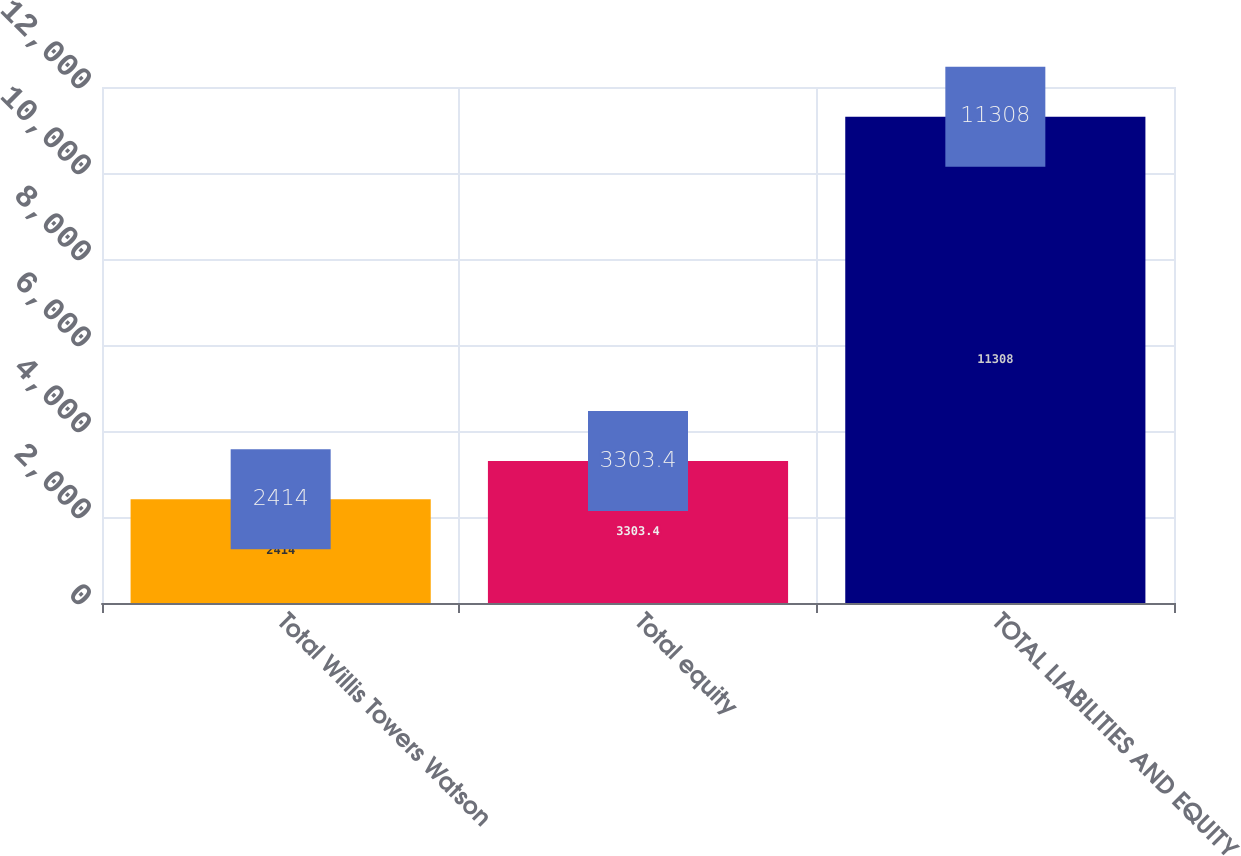<chart> <loc_0><loc_0><loc_500><loc_500><bar_chart><fcel>Total Willis Towers Watson<fcel>Total equity<fcel>TOTAL LIABILITIES AND EQUITY<nl><fcel>2414<fcel>3303.4<fcel>11308<nl></chart> 